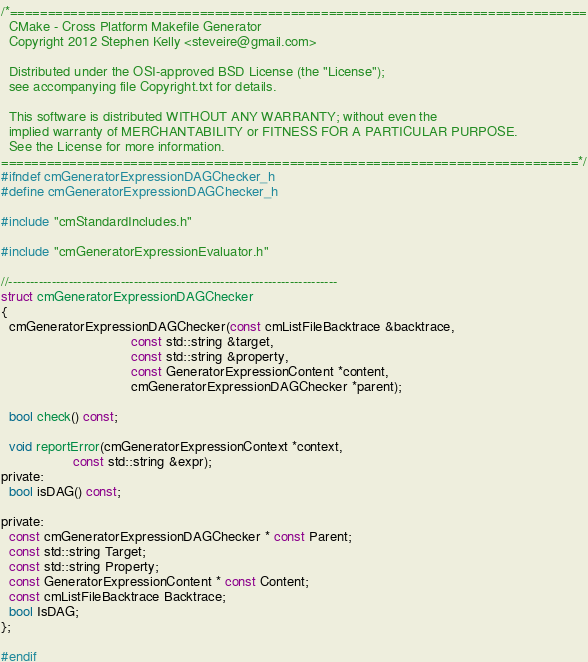<code> <loc_0><loc_0><loc_500><loc_500><_C_>/*============================================================================
  CMake - Cross Platform Makefile Generator
  Copyright 2012 Stephen Kelly <steveire@gmail.com>

  Distributed under the OSI-approved BSD License (the "License");
  see accompanying file Copyright.txt for details.

  This software is distributed WITHOUT ANY WARRANTY; without even the
  implied warranty of MERCHANTABILITY or FITNESS FOR A PARTICULAR PURPOSE.
  See the License for more information.
============================================================================*/
#ifndef cmGeneratorExpressionDAGChecker_h
#define cmGeneratorExpressionDAGChecker_h

#include "cmStandardIncludes.h"

#include "cmGeneratorExpressionEvaluator.h"

//----------------------------------------------------------------------------
struct cmGeneratorExpressionDAGChecker
{
  cmGeneratorExpressionDAGChecker(const cmListFileBacktrace &backtrace,
                                  const std::string &target,
                                  const std::string &property,
                                  const GeneratorExpressionContent *content,
                                  cmGeneratorExpressionDAGChecker *parent);

  bool check() const;

  void reportError(cmGeneratorExpressionContext *context,
                   const std::string &expr);
private:
  bool isDAG() const;

private:
  const cmGeneratorExpressionDAGChecker * const Parent;
  const std::string Target;
  const std::string Property;
  const GeneratorExpressionContent * const Content;
  const cmListFileBacktrace Backtrace;
  bool IsDAG;
};

#endif
</code> 